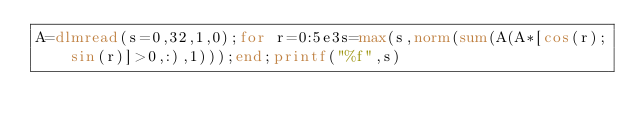Convert code to text. <code><loc_0><loc_0><loc_500><loc_500><_Octave_>A=dlmread(s=0,32,1,0);for r=0:5e3s=max(s,norm(sum(A(A*[cos(r);sin(r)]>0,:),1)));end;printf("%f",s)</code> 